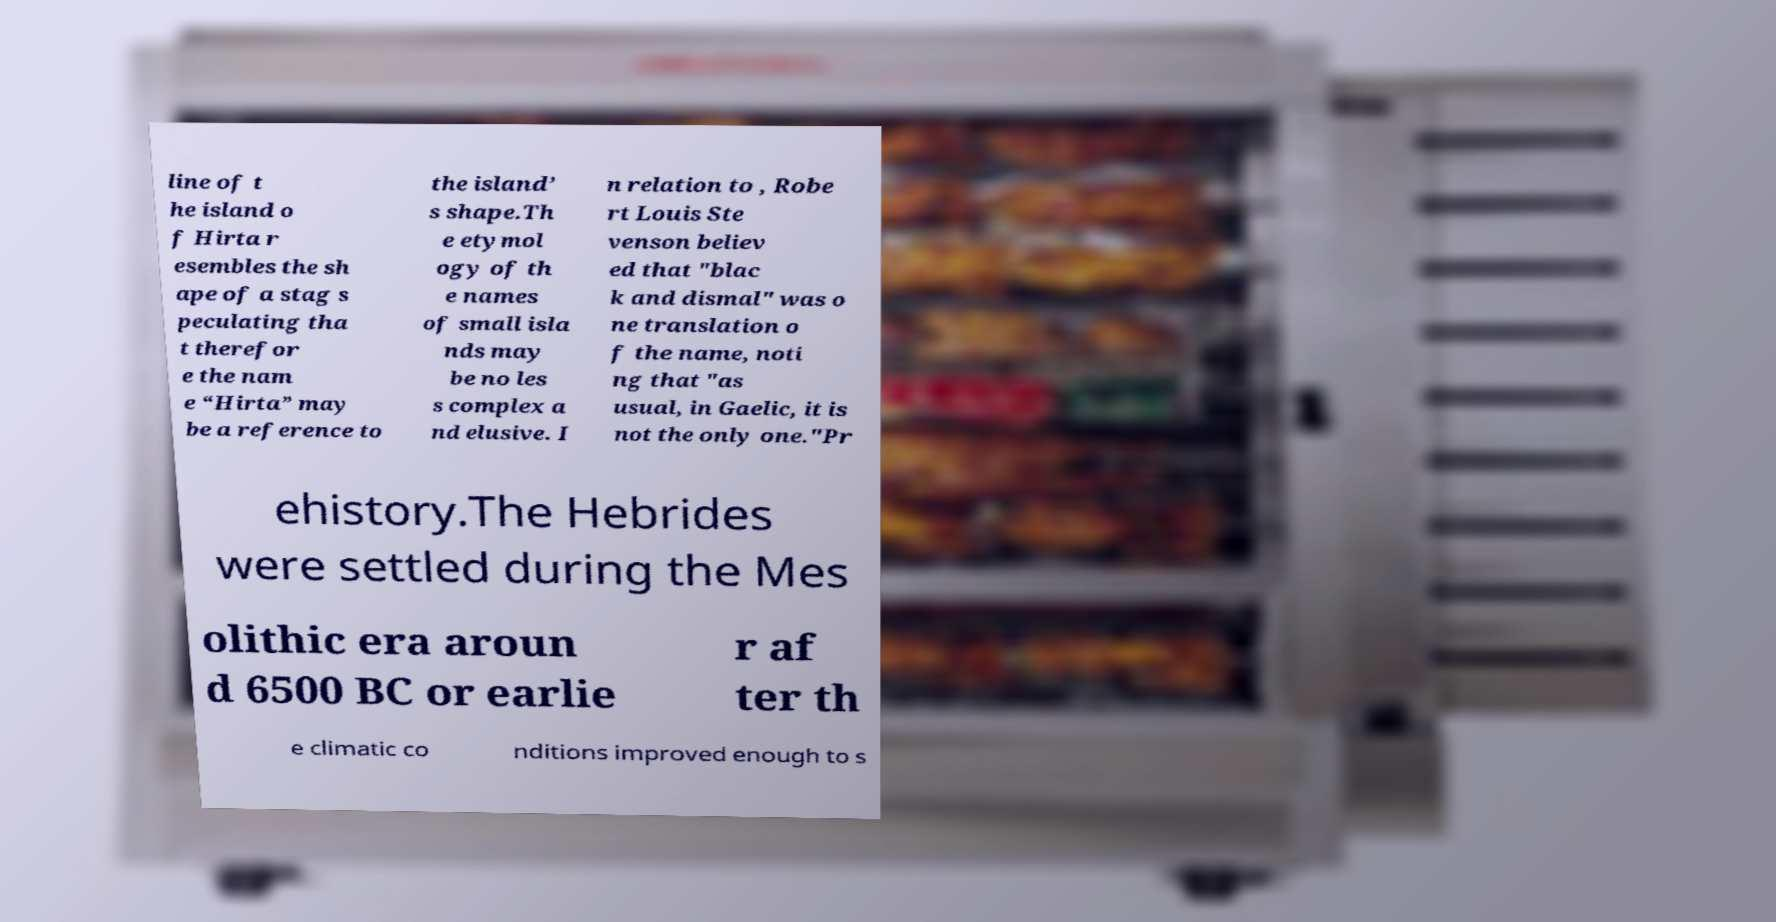I need the written content from this picture converted into text. Can you do that? line of t he island o f Hirta r esembles the sh ape of a stag s peculating tha t therefor e the nam e “Hirta” may be a reference to the island’ s shape.Th e etymol ogy of th e names of small isla nds may be no les s complex a nd elusive. I n relation to , Robe rt Louis Ste venson believ ed that "blac k and dismal" was o ne translation o f the name, noti ng that "as usual, in Gaelic, it is not the only one."Pr ehistory.The Hebrides were settled during the Mes olithic era aroun d 6500 BC or earlie r af ter th e climatic co nditions improved enough to s 